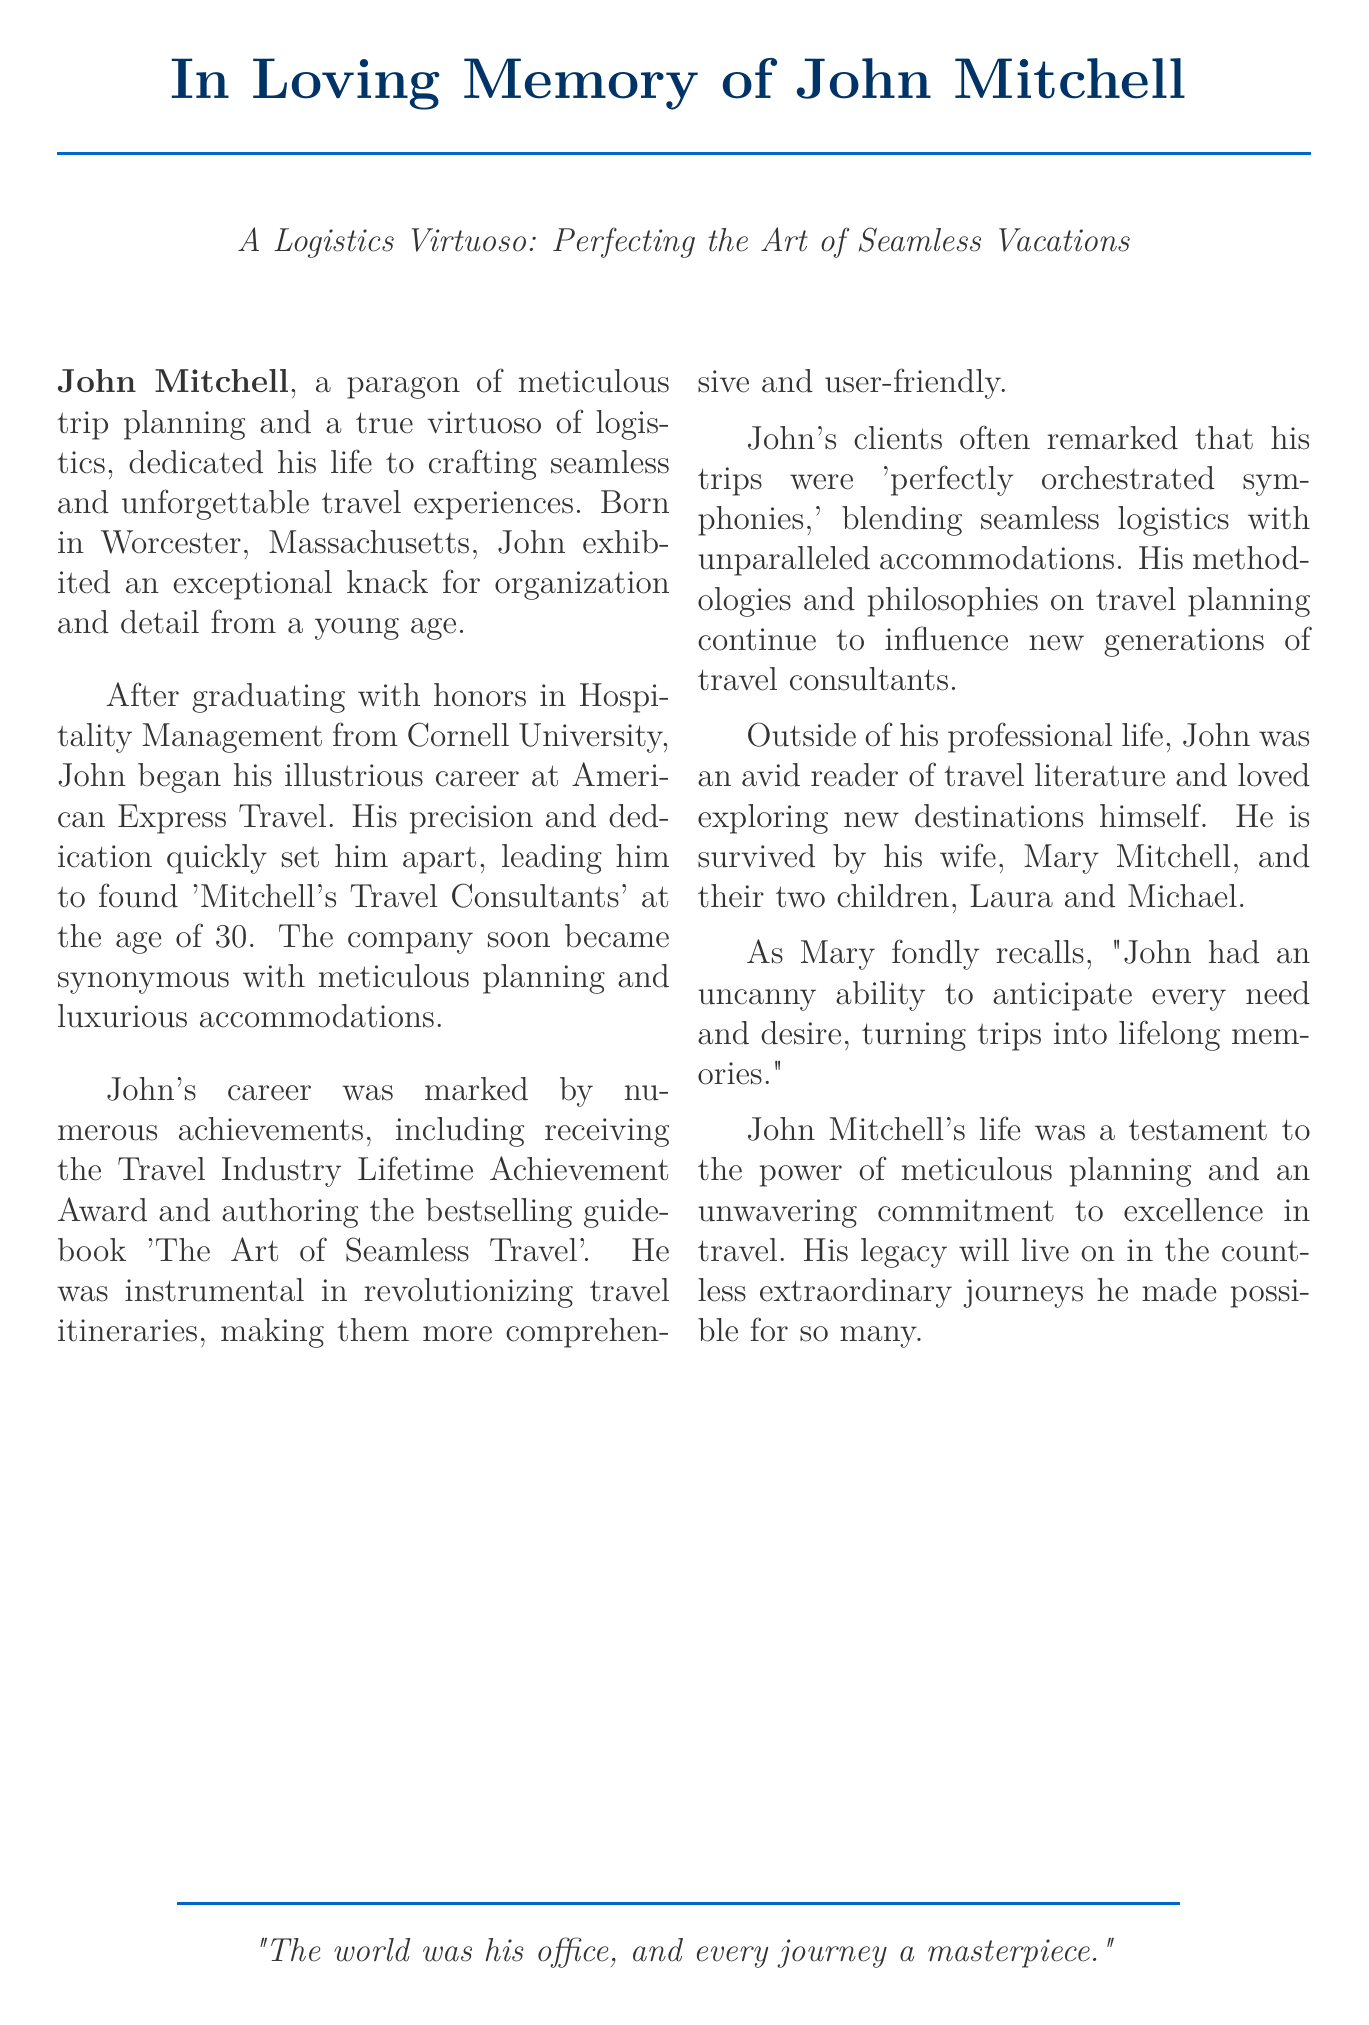What is the full name of the individual being memorialized? The document begins by stating "In Loving Memory of John Mitchell," which indicates the individual's full name.
Answer: John Mitchell What award did John receive for his contributions to the travel industry? The document mentions that John received the Travel Industry Lifetime Achievement Award as a notable achievement in his career.
Answer: Travel Industry Lifetime Achievement Award What was the name of the company John Mitchell founded? The document states that John founded "Mitchell's Travel Consultants," highlighting his entrepreneurial achievement.
Answer: Mitchell's Travel Consultants When did John Mitchell found his travel company? The document notes that he founded his company at the age of 30, which provides insight into his career trajectory.
Answer: Age 30 What degree did John earn from Cornell University? It is stated that John graduated with honors in Hospitality Management, clarifying his educational background.
Answer: Hospitality Management Who are John's surviving family members mentioned in the document? The document lists his wife, Mary Mitchell, and their two children, Laura and Michael, as his survivors.
Answer: Mary Mitchell, Laura, Michael What was one of John's significant contributions to travel planning? The obituary notes that he was instrumental in revolutionizing travel itineraries, making them more comprehensive and user-friendly, indicating his impact on the industry.
Answer: Revolutionizing travel itineraries How did clients describe John's travel trips? The document quotes clients describing John's trips as "perfectly orchestrated symphonies," which reflects the quality of his work.
Answer: Perfectly orchestrated symphonies Who expressed a fond memory of John in the document? The obituary mentions Mary recalling John's ability to anticipate needs, which signifies the personal connection and impact he had on his family.
Answer: Mary Mitchell 